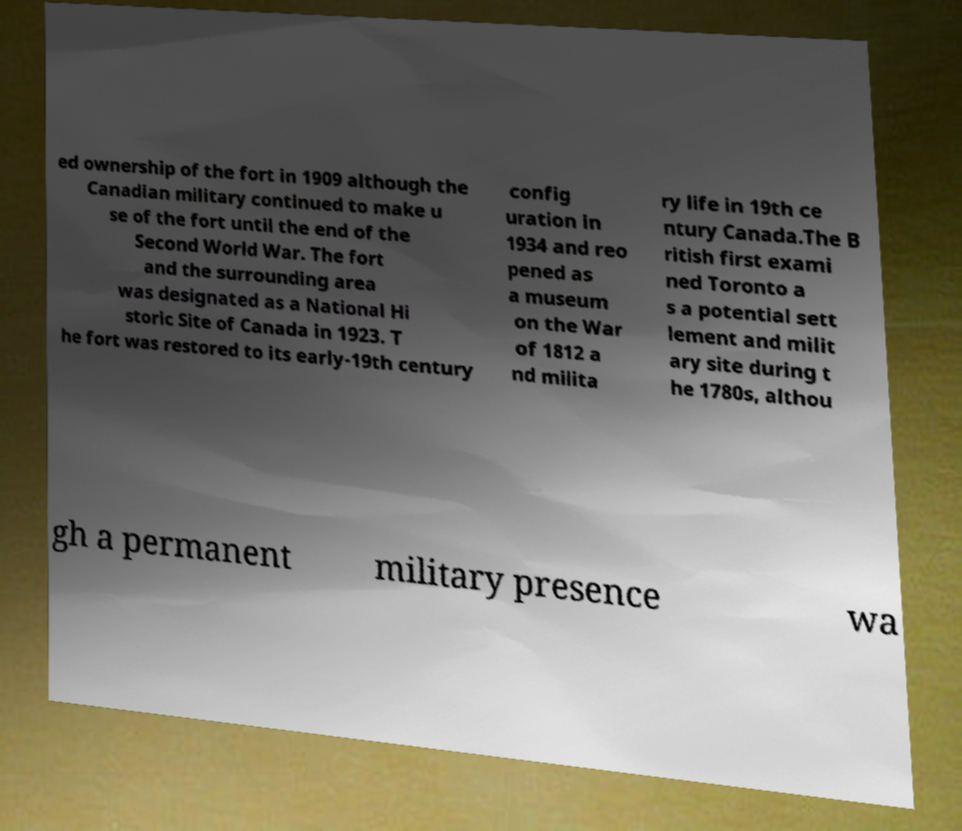Could you extract and type out the text from this image? ed ownership of the fort in 1909 although the Canadian military continued to make u se of the fort until the end of the Second World War. The fort and the surrounding area was designated as a National Hi storic Site of Canada in 1923. T he fort was restored to its early-19th century config uration in 1934 and reo pened as a museum on the War of 1812 a nd milita ry life in 19th ce ntury Canada.The B ritish first exami ned Toronto a s a potential sett lement and milit ary site during t he 1780s, althou gh a permanent military presence wa 